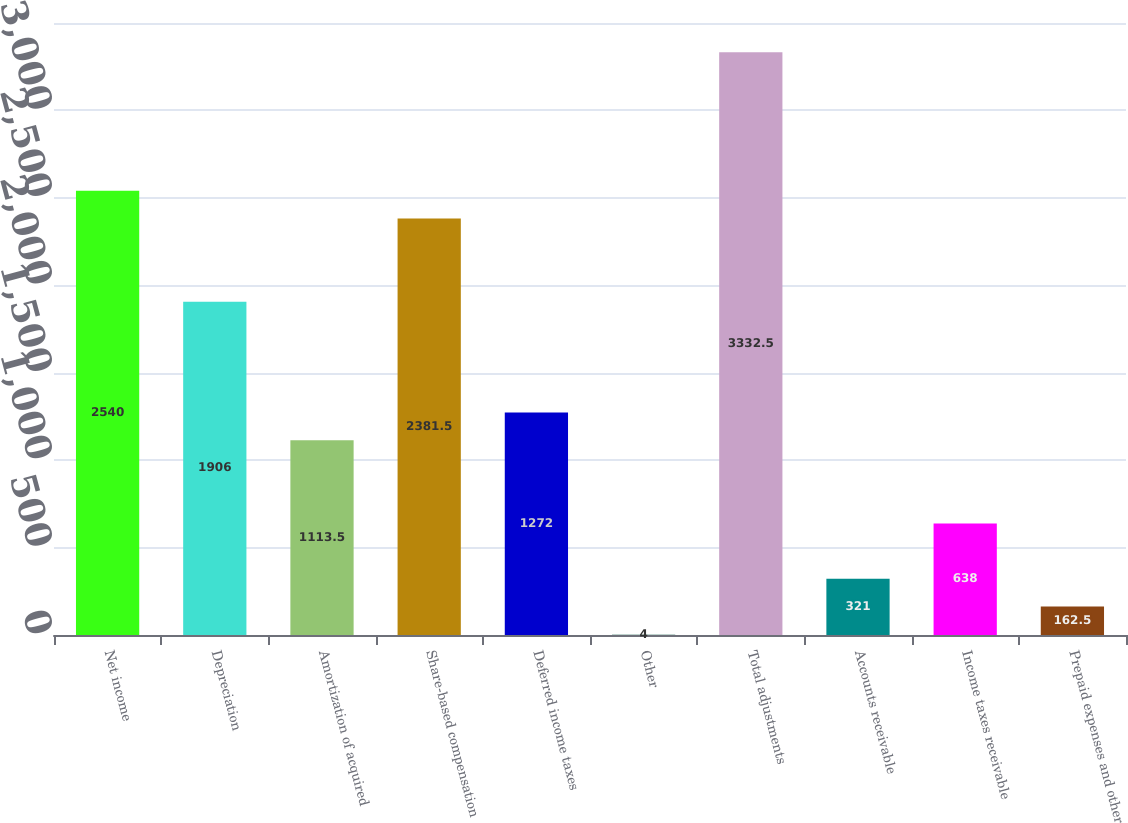Convert chart to OTSL. <chart><loc_0><loc_0><loc_500><loc_500><bar_chart><fcel>Net income<fcel>Depreciation<fcel>Amortization of acquired<fcel>Share-based compensation<fcel>Deferred income taxes<fcel>Other<fcel>Total adjustments<fcel>Accounts receivable<fcel>Income taxes receivable<fcel>Prepaid expenses and other<nl><fcel>2540<fcel>1906<fcel>1113.5<fcel>2381.5<fcel>1272<fcel>4<fcel>3332.5<fcel>321<fcel>638<fcel>162.5<nl></chart> 